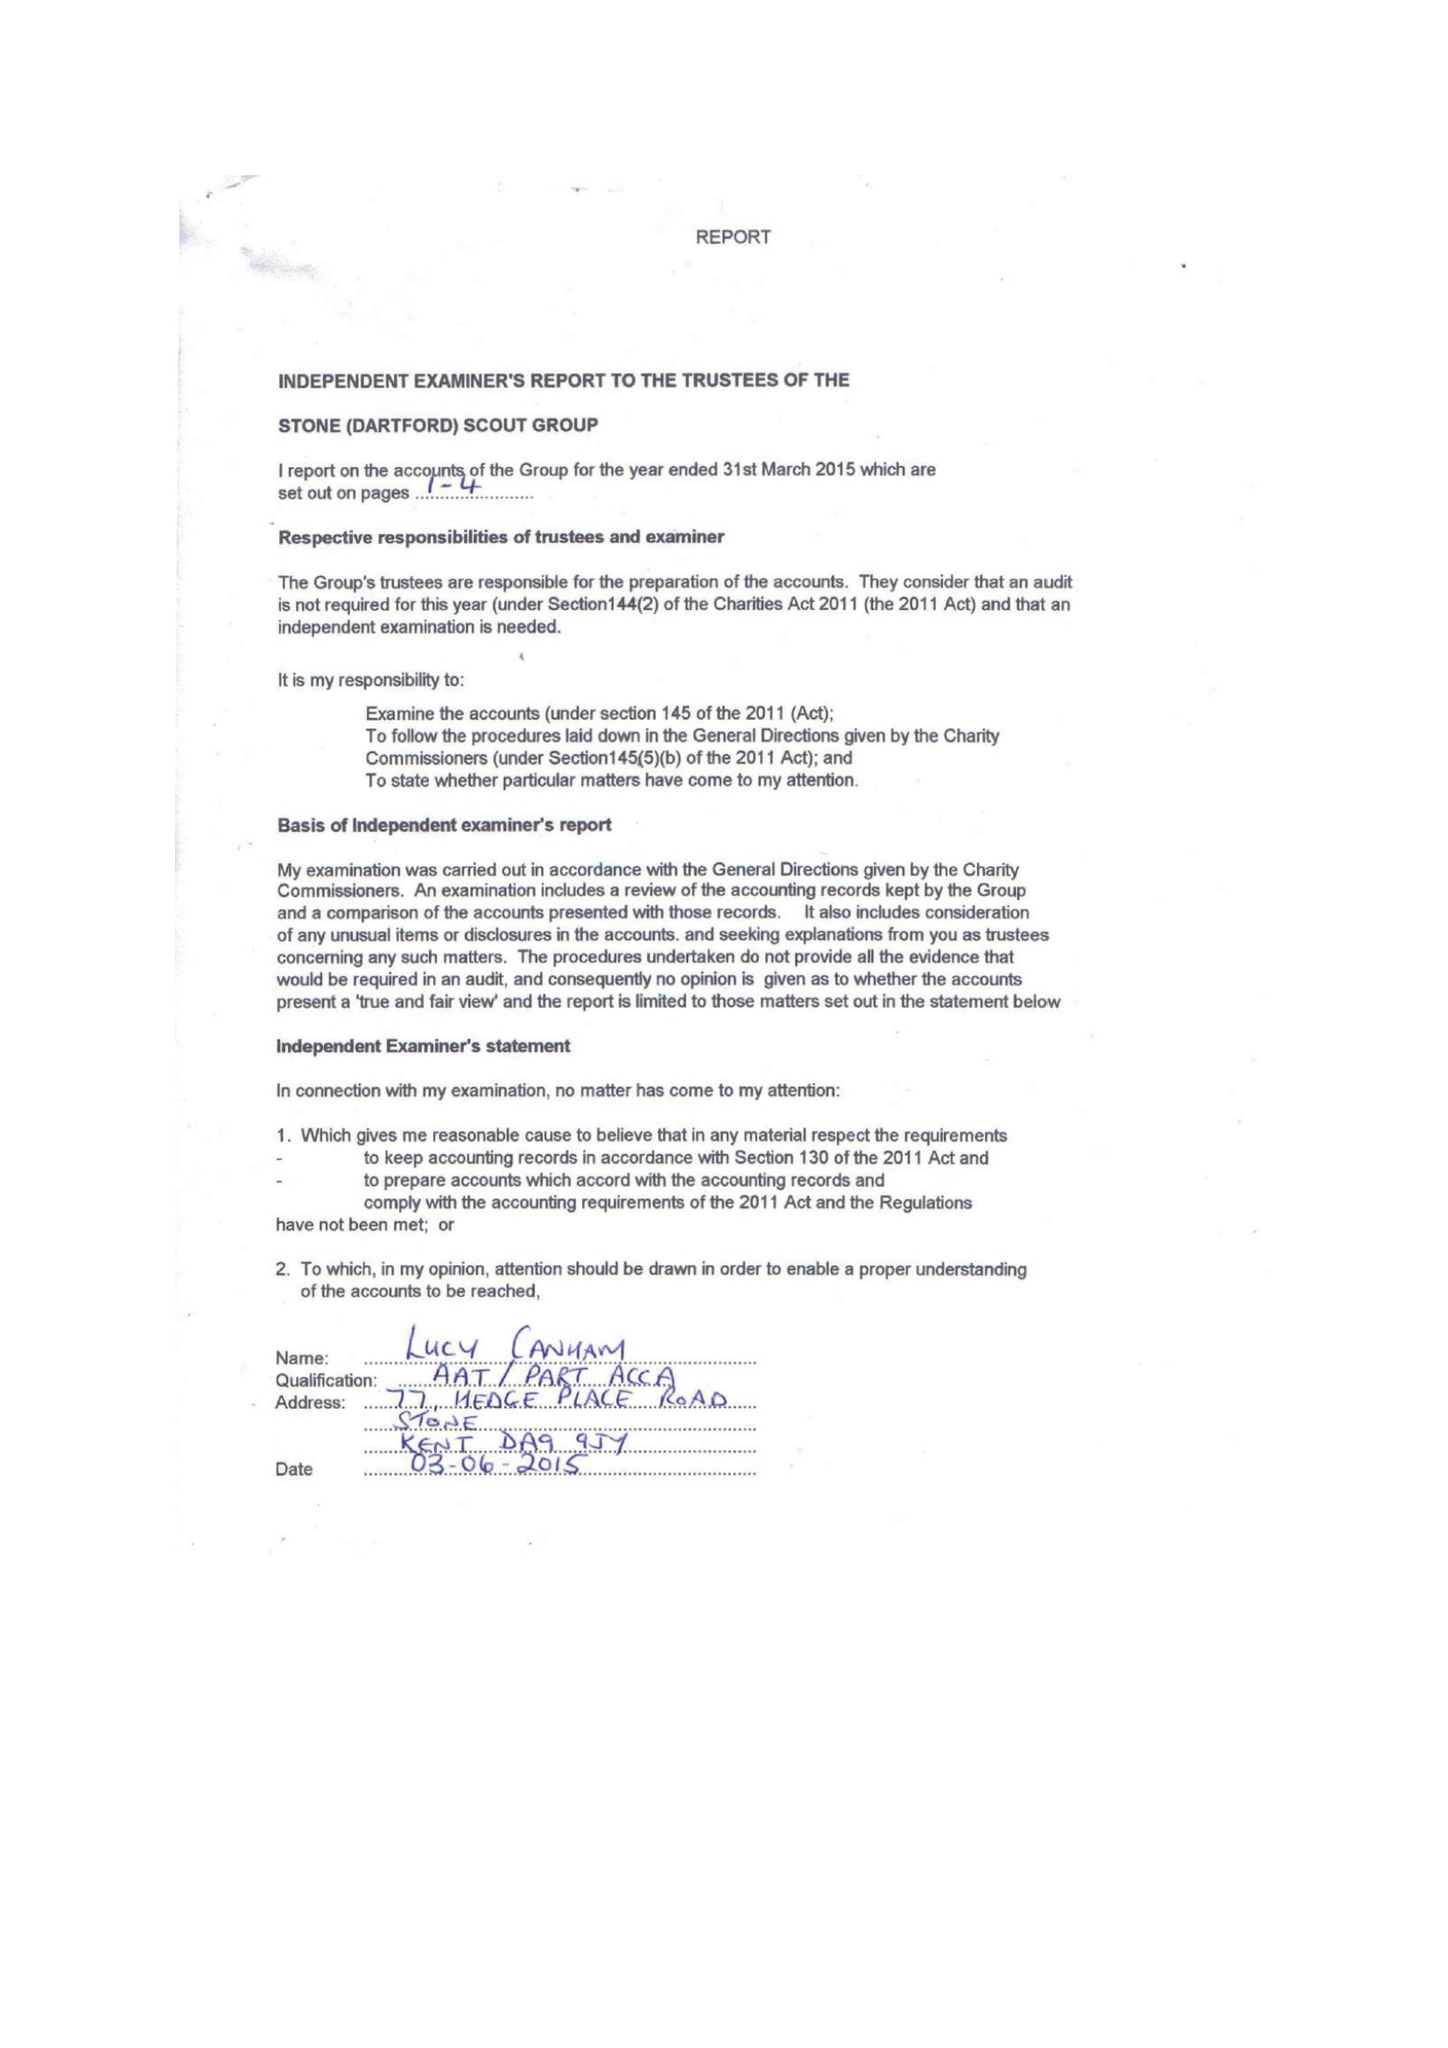What is the value for the spending_annually_in_british_pounds?
Answer the question using a single word or phrase. 40316.00 